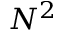<formula> <loc_0><loc_0><loc_500><loc_500>N ^ { 2 }</formula> 